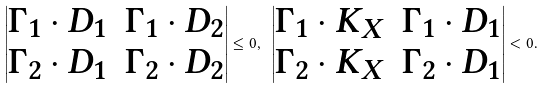Convert formula to latex. <formula><loc_0><loc_0><loc_500><loc_500>\begin{vmatrix} \Gamma _ { 1 } \cdot D _ { 1 } & \Gamma _ { 1 } \cdot D _ { 2 } \\ \Gamma _ { 2 } \cdot D _ { 1 } & \Gamma _ { 2 } \cdot D _ { 2 } \\ \end{vmatrix} \leq 0 , \ \begin{vmatrix} \Gamma _ { 1 } \cdot K _ { X } & \Gamma _ { 1 } \cdot D _ { 1 } \\ \Gamma _ { 2 } \cdot K _ { X } & \Gamma _ { 2 } \cdot D _ { 1 } \\ \end{vmatrix} < 0 .</formula> 